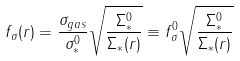Convert formula to latex. <formula><loc_0><loc_0><loc_500><loc_500>f _ { \sigma } ( r ) = \frac { \sigma _ { g a s } } { \sigma _ { * } ^ { 0 } } \sqrt { \frac { \Sigma _ { * } ^ { 0 } } { \Sigma _ { * } ( r ) } } \equiv f ^ { 0 } _ { \sigma } \sqrt { \frac { \Sigma _ { * } ^ { 0 } } { \Sigma _ { * } ( r ) } }</formula> 